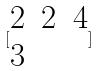<formula> <loc_0><loc_0><loc_500><loc_500>[ \begin{matrix} 2 & 2 & 4 \\ 3 \end{matrix} ]</formula> 